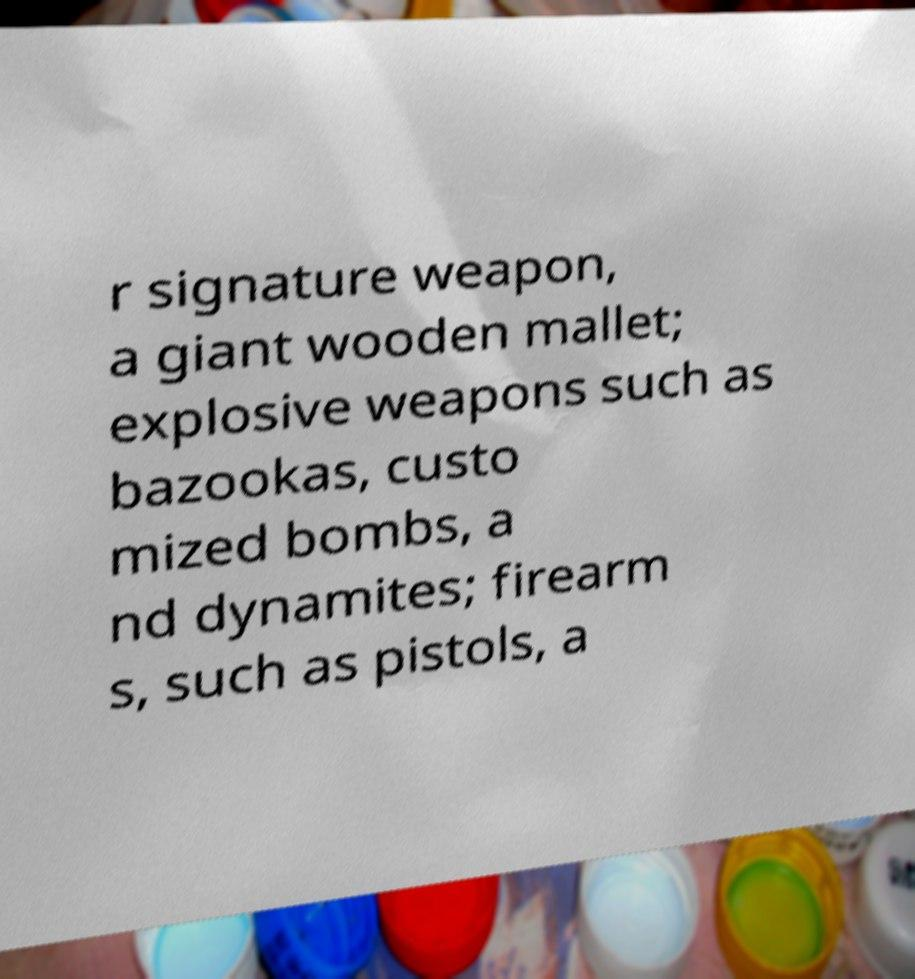Could you assist in decoding the text presented in this image and type it out clearly? r signature weapon, a giant wooden mallet; explosive weapons such as bazookas, custo mized bombs, a nd dynamites; firearm s, such as pistols, a 